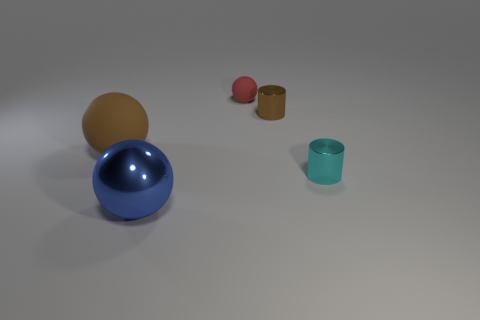Are there more tiny red objects that are in front of the red matte object than red rubber objects on the left side of the blue object?
Your answer should be compact. No. Are there any yellow rubber cylinders of the same size as the red matte thing?
Provide a short and direct response. No. What is the size of the shiny object that is behind the big object that is behind the big shiny object that is in front of the tiny brown metallic object?
Keep it short and to the point. Small. The shiny sphere has what color?
Offer a very short reply. Blue. Are there more brown rubber spheres right of the small cyan shiny cylinder than large matte spheres?
Give a very brief answer. No. There is a big blue ball; how many brown shiny things are behind it?
Your answer should be compact. 1. What shape is the small shiny thing that is the same color as the large matte ball?
Provide a short and direct response. Cylinder. There is a rubber object that is in front of the brown thing right of the big blue thing; is there a red sphere on the left side of it?
Keep it short and to the point. No. Does the red ball have the same size as the brown sphere?
Your answer should be compact. No. Are there the same number of small brown objects in front of the tiny brown metallic object and cyan shiny objects that are behind the tiny cyan metal thing?
Offer a terse response. Yes. 